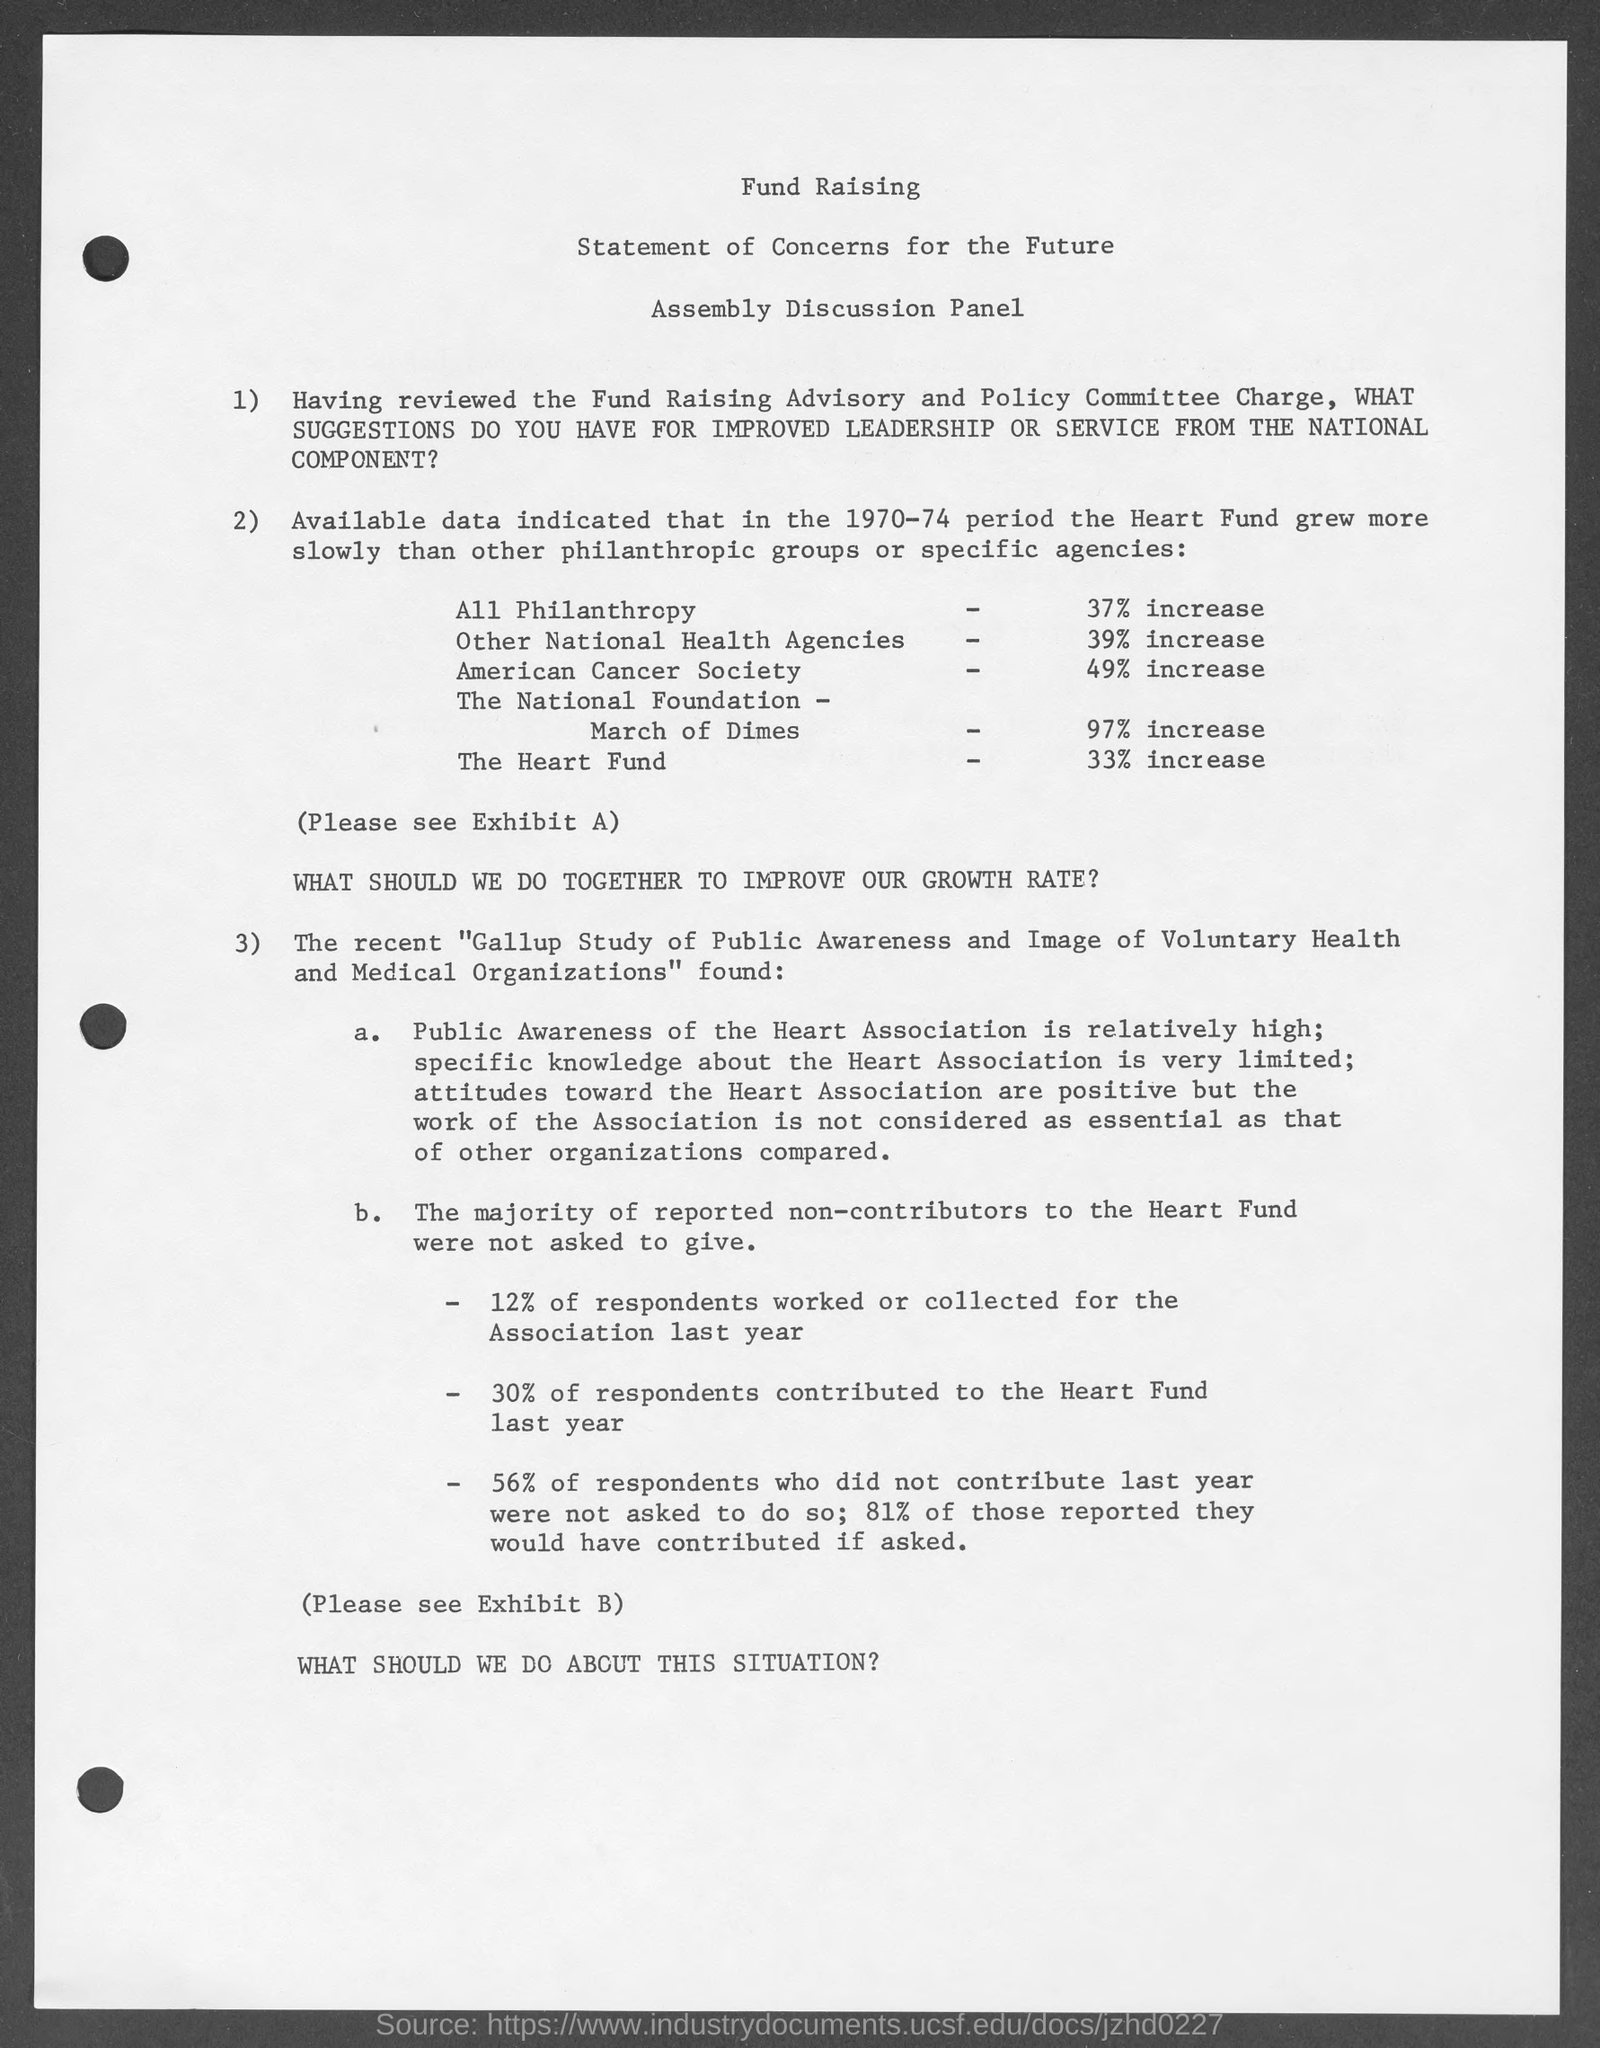What is the first title in the document?
Offer a very short reply. Fund raising. What is the % increase of the heart fund?
Your answer should be compact. 33% increase. What is the % increase of all philanthropy?
Ensure brevity in your answer.  37% increase. What is the % increase in American cancer society?
Your answer should be compact. 49%. 